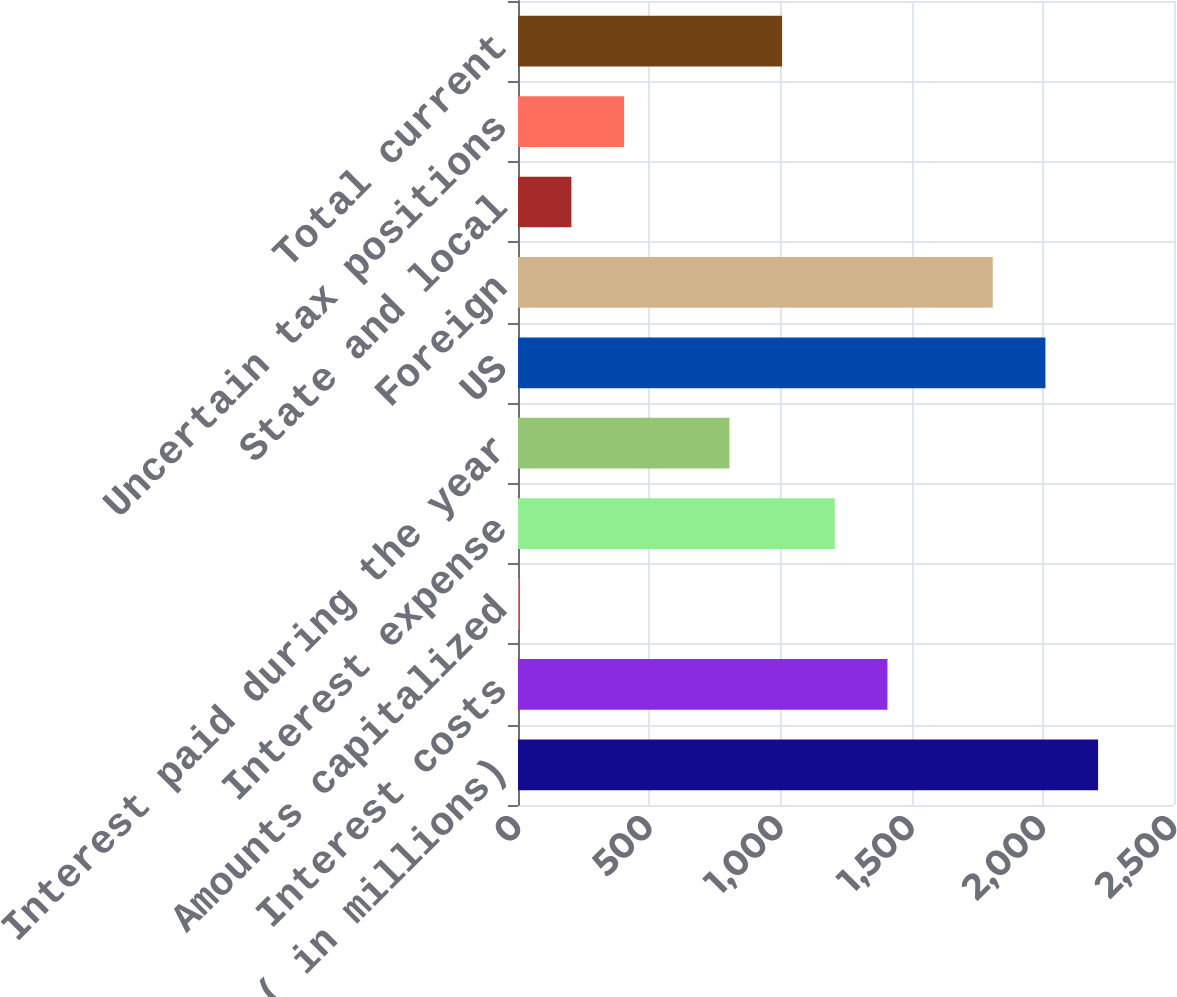<chart> <loc_0><loc_0><loc_500><loc_500><bar_chart><fcel>( in millions)<fcel>Interest costs<fcel>Amounts capitalized<fcel>Interest expense<fcel>Interest paid during the year<fcel>US<fcel>Foreign<fcel>State and local<fcel>Uncertain tax positions<fcel>Total current<nl><fcel>2210.71<fcel>1407.87<fcel>2.9<fcel>1207.16<fcel>805.74<fcel>2010<fcel>1809.29<fcel>203.61<fcel>404.32<fcel>1006.45<nl></chart> 